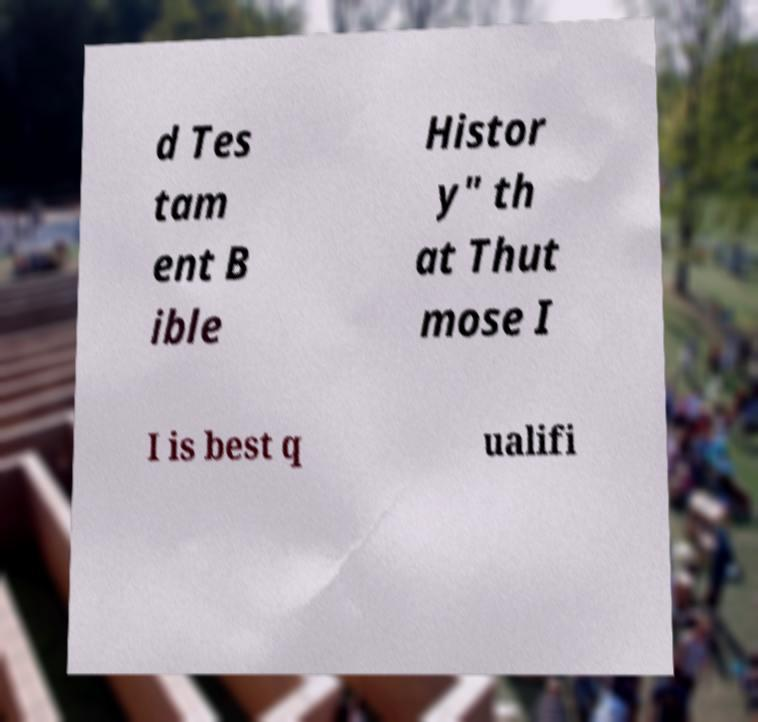There's text embedded in this image that I need extracted. Can you transcribe it verbatim? d Tes tam ent B ible Histor y" th at Thut mose I I is best q ualifi 